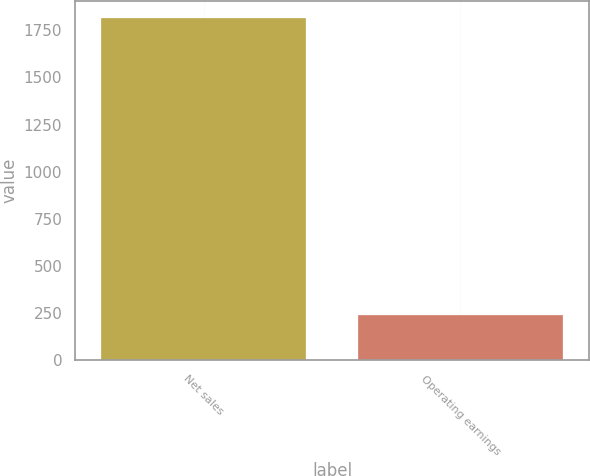<chart> <loc_0><loc_0><loc_500><loc_500><bar_chart><fcel>Net sales<fcel>Operating earnings<nl><fcel>1814<fcel>239<nl></chart> 